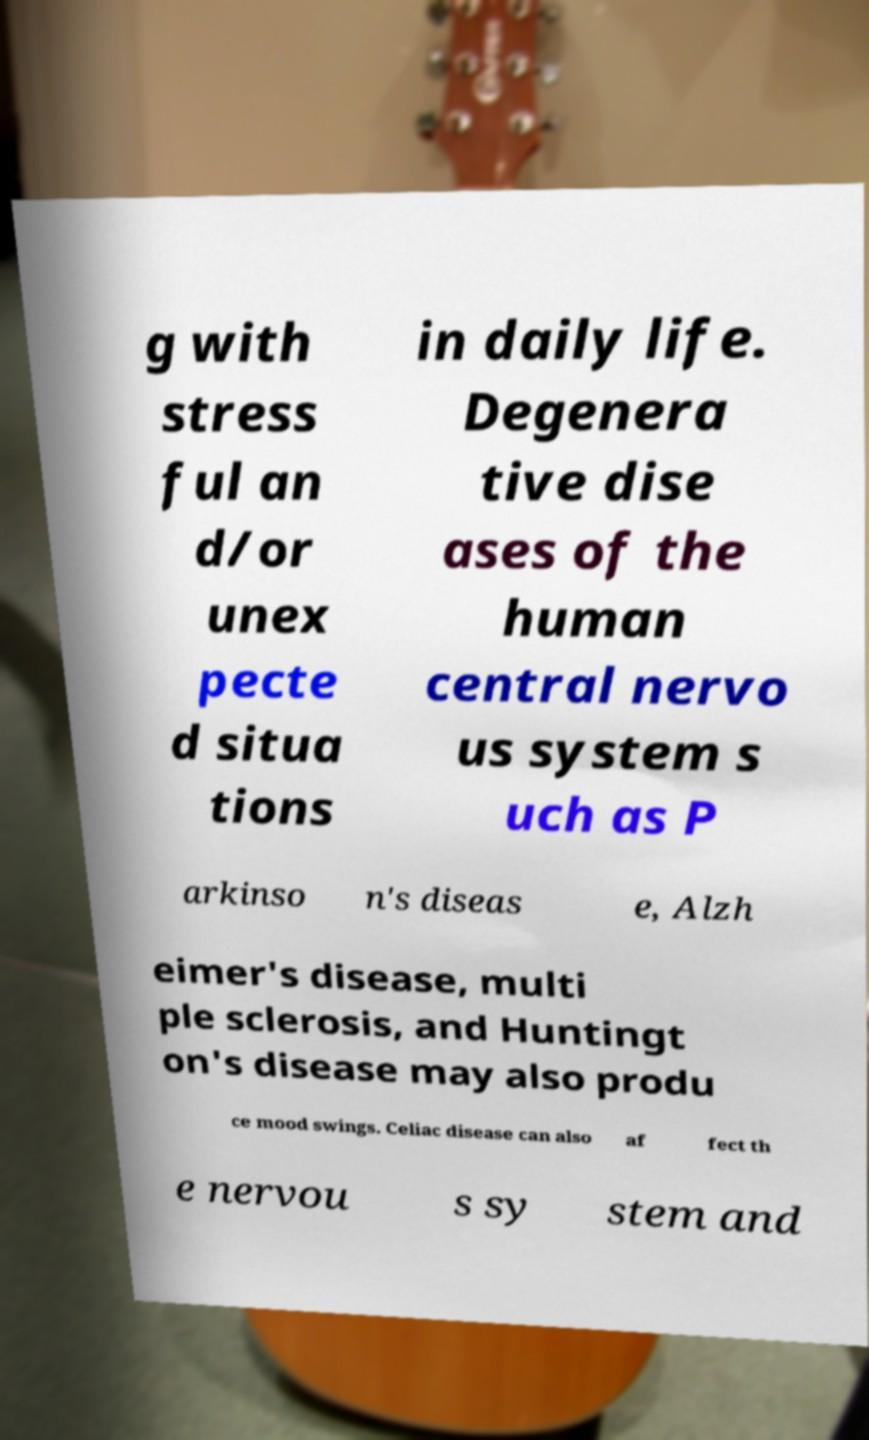Can you accurately transcribe the text from the provided image for me? g with stress ful an d/or unex pecte d situa tions in daily life. Degenera tive dise ases of the human central nervo us system s uch as P arkinso n's diseas e, Alzh eimer's disease, multi ple sclerosis, and Huntingt on's disease may also produ ce mood swings. Celiac disease can also af fect th e nervou s sy stem and 